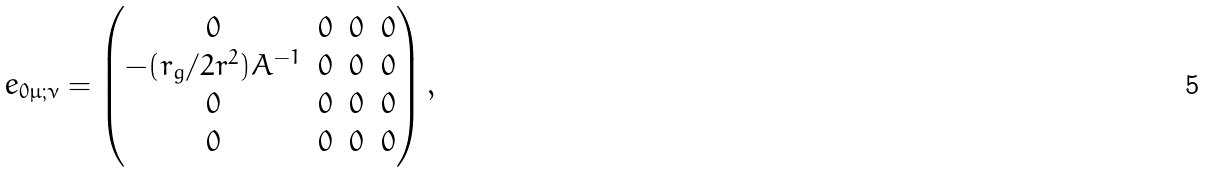Convert formula to latex. <formula><loc_0><loc_0><loc_500><loc_500>e _ { 0 \mu ; \nu } = \begin{pmatrix} 0 & 0 & 0 & 0 \\ - ( r _ { g } / 2 r ^ { 2 } ) A ^ { - 1 } & 0 & 0 & 0 \\ 0 & 0 & 0 & 0 \\ 0 & 0 & 0 & 0 \end{pmatrix} ,</formula> 